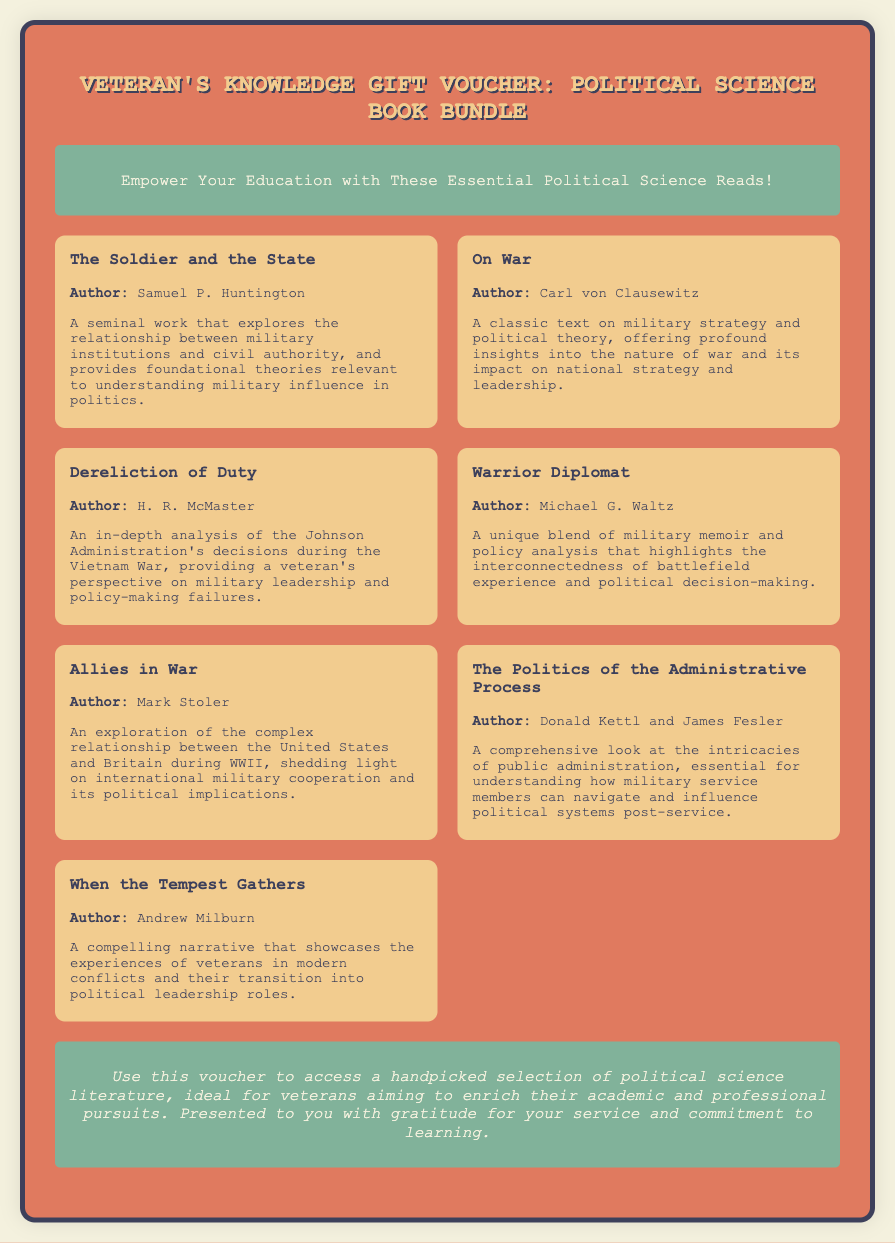What is the title of the voucher? The title of the document is clearly stated at the top as "Veteran's Knowledge Gift Voucher: Political Science Book Bundle."
Answer: Veteran's Knowledge Gift Voucher: Political Science Book Bundle Who is the author of "The Soldier and the State"? The author of "The Soldier and the State" is mentioned in the document, and it is Samuel P. Huntington.
Answer: Samuel P. Huntington How many books are included in the bundle? The document presents a total of seven distinct books in the book bundle section.
Answer: 7 What is the focus of "Warrior Diplomat"? The description provided in the document indicates that "Warrior Diplomat" highlights the interconnectedness of battlefield experience and political decision-making.
Answer: Interconnectedness of battlefield experience and political decision-making Which book discusses the Vietnam War and military leadership? The document describes "Dereliction of Duty" as providing an in-depth analysis of the Johnson Administration's decisions during the Vietnam War.
Answer: Dereliction of Duty What type of reading does the voucher promote for veterans? The document emphasizes the importance of political science literature aimed at veterans seeking to enrich their academic and professional pursuits.
Answer: Political science literature What is the primary theme of "When the Tempest Gathers"? The document summarizes "When the Tempest Gathers" as showcasing the experiences of veterans in modern conflicts and their transition into political leadership roles.
Answer: Veterans' transition into political leadership roles 